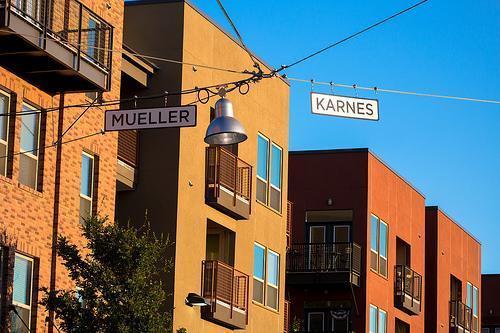How many signs are there?
Give a very brief answer. 2. 